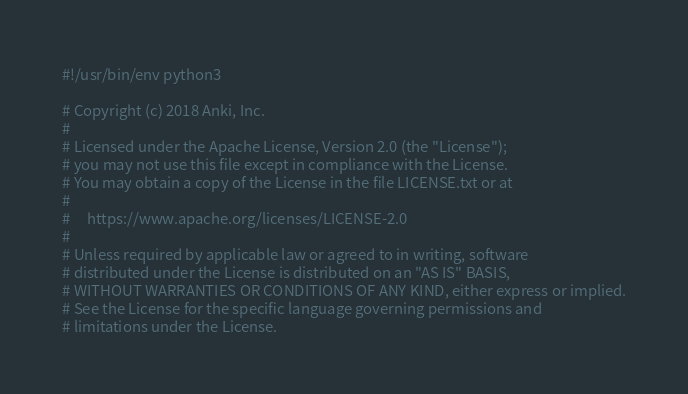<code> <loc_0><loc_0><loc_500><loc_500><_Python_>#!/usr/bin/env python3

# Copyright (c) 2018 Anki, Inc.
#
# Licensed under the Apache License, Version 2.0 (the "License");
# you may not use this file except in compliance with the License.
# You may obtain a copy of the License in the file LICENSE.txt or at
#
#     https://www.apache.org/licenses/LICENSE-2.0
#
# Unless required by applicable law or agreed to in writing, software
# distributed under the License is distributed on an "AS IS" BASIS,
# WITHOUT WARRANTIES OR CONDITIONS OF ANY KIND, either express or implied.
# See the License for the specific language governing permissions and
# limitations under the License.
</code> 